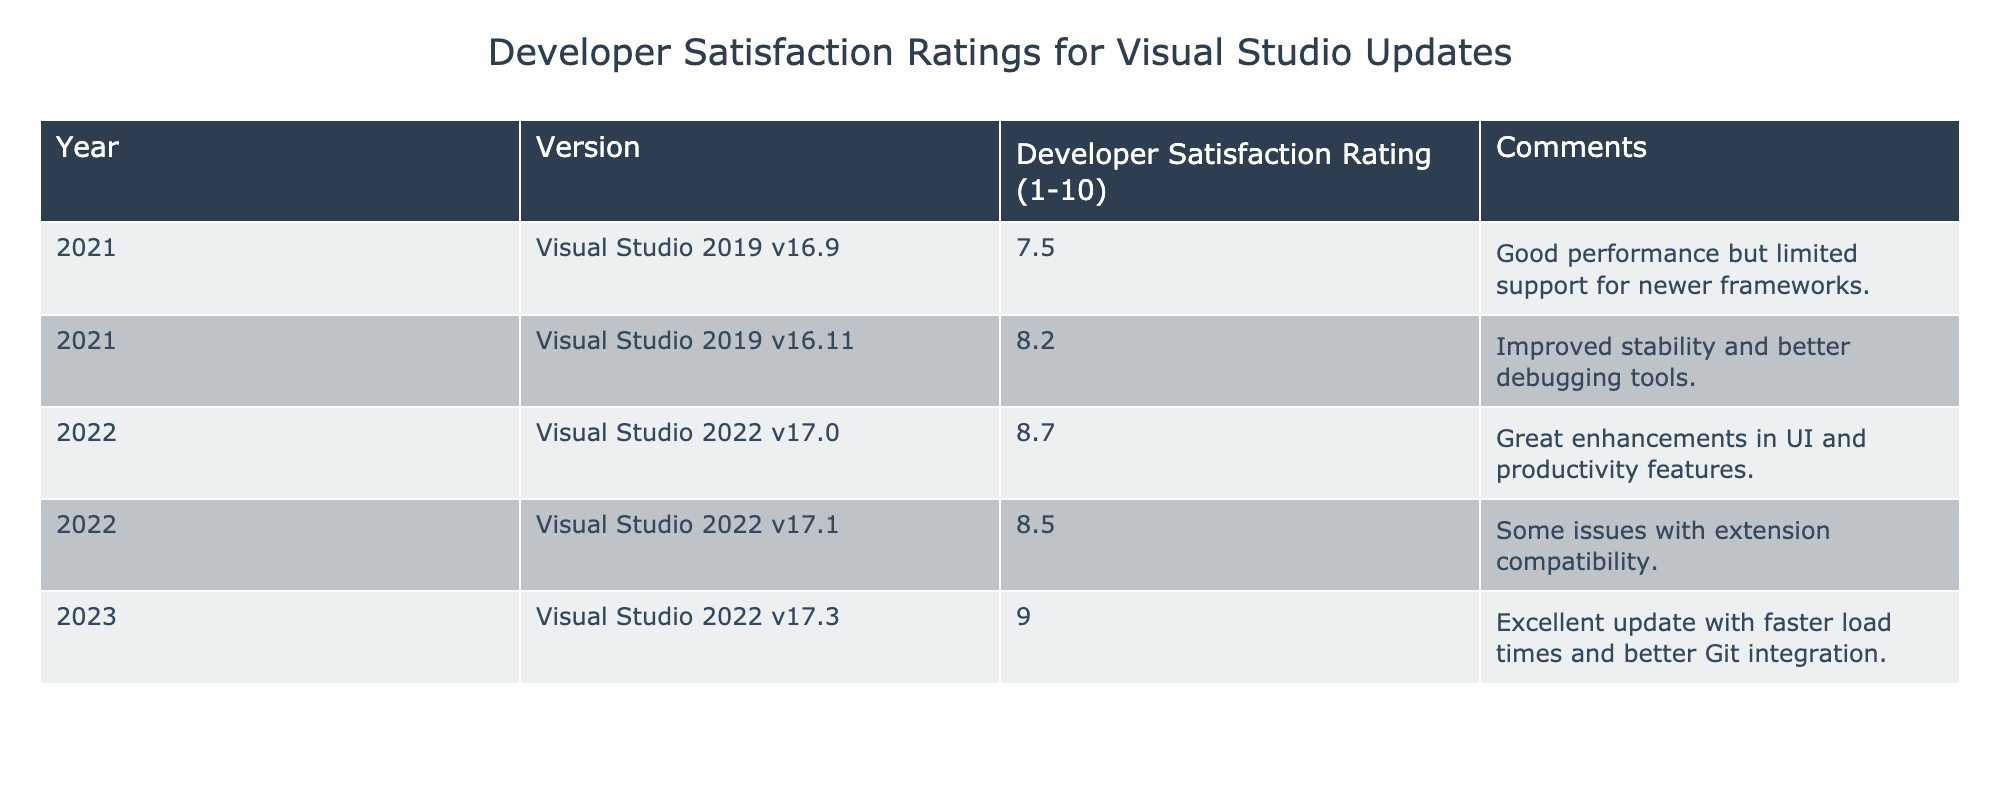What was the satisfaction rating for Visual Studio 2019 v16.11? The table states that the Developer Satisfaction Rating for Visual Studio 2019 v16.11 is 8.2.
Answer: 8.2 Which version released in 2022 had the highest satisfaction rating? According to the table, Visual Studio 2022 v17.0 has the highest rating among the 2022 versions at 8.7.
Answer: Visual Studio 2022 v17.0 What is the average Developer Satisfaction Rating for all versions from 2021? The ratings for 2021 are 7.5 and 8.2. The average is (7.5 + 8.2) / 2 = 7.85.
Answer: 7.85 Did any version released in 2023 have a satisfaction rating lower than 9.0? The only version listed for 2023 is Visual Studio 2022 v17.3 with a rating of 9.0, which means no version has a lower rating.
Answer: No What was the change in satisfaction rating from Visual Studio 2019 v16.9 to Visual Studio 2022 v17.1? The satisfaction rating for Visual Studio 2019 v16.9 is 7.5 and for 2022 v17.1 is 8.5. The change is 8.5 - 7.5 = 1.0, indicating an increase.
Answer: 1.0 Which version has better developer satisfaction: Visual Studio 2022 v17.1 or Visual Studio 2022 v17.3? Comparing the ratings, Visual Studio 2022 v17.1 has a satisfaction rating of 8.5, while v17.3 has a rating of 9.0, showing that v17.3 is better.
Answer: Visual Studio 2022 v17.3 What common comment was noted for the updates in the table? The table mentions various comments regarding performance, stability, and compatibility. However, specific comments differ across versions, so there isn't a repeated comment.
Answer: No common comment How does the satisfaction rating for Visual Studio 2022 v17.0 compare to its preceding version? The preceding version, Visual Studio 2021 v16.11 has a rating of 8.2, while v17.0 has a rating of 8.7. Thus, v17.0 has a higher rating by 0.5.
Answer: Higher by 0.5 